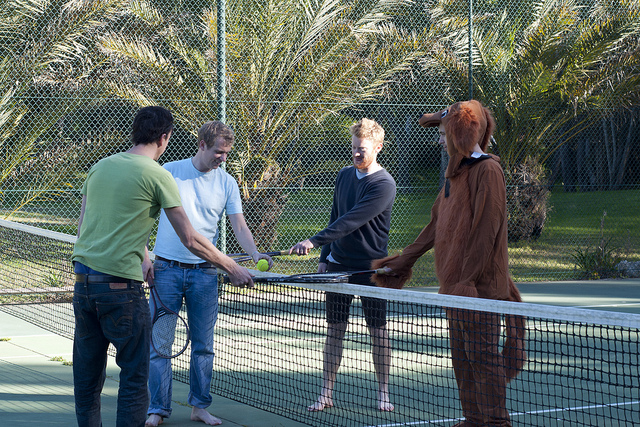Please provide the bounding box coordinate of the region this sentence describes: right person. [0.58, 0.32, 0.82, 0.83] 